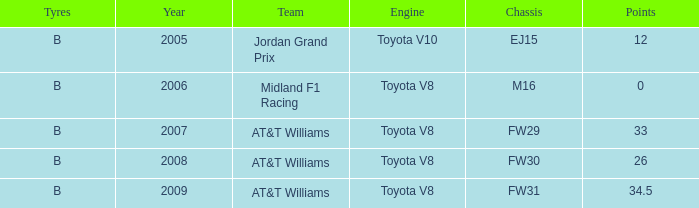What is the earliest year that had under 26 points and a toyota v8 engine? 2006.0. 